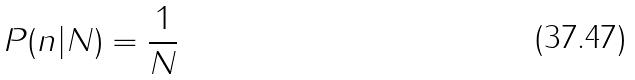<formula> <loc_0><loc_0><loc_500><loc_500>P ( n | N ) = \frac { 1 } { N }</formula> 